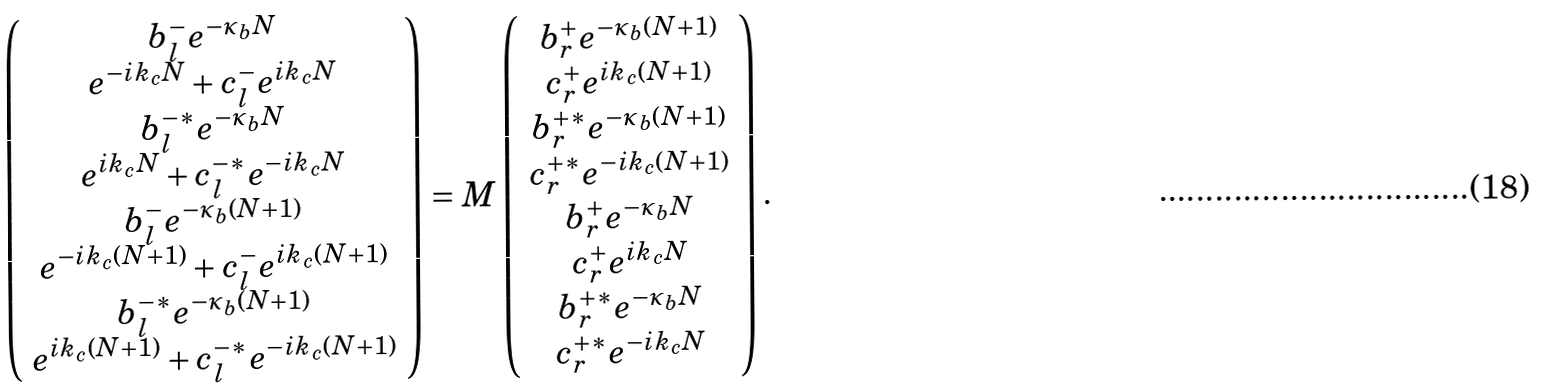Convert formula to latex. <formula><loc_0><loc_0><loc_500><loc_500>\left ( \begin{array} { c } b _ { l } ^ { - } e ^ { - \kappa _ { b } N } \\ e ^ { - i k _ { c } N } + c _ { l } ^ { - } e ^ { i k _ { c } N } \\ b _ { l } ^ { - * } e ^ { - \kappa _ { b } N } \\ e ^ { i k _ { c } N } + c _ { l } ^ { - * } e ^ { - i k _ { c } N } \\ b _ { l } ^ { - } e ^ { - \kappa _ { b } ( N + 1 ) } \\ e ^ { - i k _ { c } ( N + 1 ) } + c _ { l } ^ { - } e ^ { i k _ { c } ( N + 1 ) } \\ b _ { l } ^ { - * } e ^ { - \kappa _ { b } ( N + 1 ) } \\ e ^ { i k _ { c } ( N + 1 ) } + c _ { l } ^ { - * } e ^ { - i k _ { c } ( N + 1 ) } \end{array} \right ) = M \left ( \begin{array} { c } b _ { r } ^ { + } e ^ { - \kappa _ { b } ( N + 1 ) } \\ c _ { r } ^ { + } e ^ { i k _ { c } ( N + 1 ) } \\ b _ { r } ^ { + * } e ^ { - \kappa _ { b } ( N + 1 ) } \\ c _ { r } ^ { + * } e ^ { - i k _ { c } ( N + 1 ) } \\ b _ { r } ^ { + } e ^ { - \kappa _ { b } N } \\ c _ { r } ^ { + } e ^ { i k _ { c } N } \\ b _ { r } ^ { + * } e ^ { - \kappa _ { b } N } \\ c _ { r } ^ { + * } e ^ { - i k _ { c } N } \end{array} \right ) .</formula> 